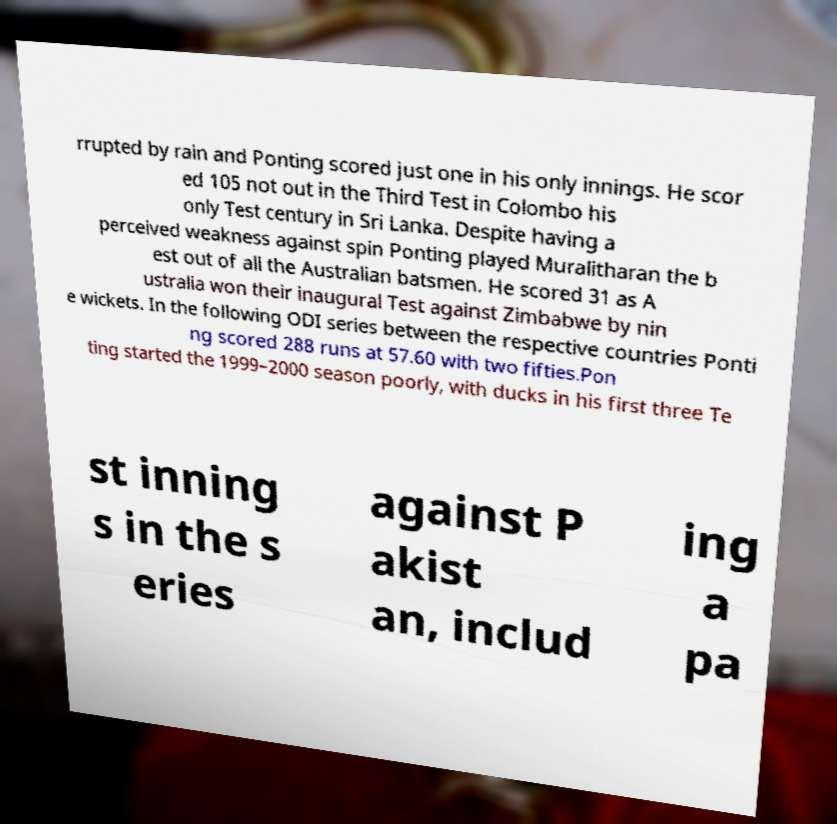I need the written content from this picture converted into text. Can you do that? rrupted by rain and Ponting scored just one in his only innings. He scor ed 105 not out in the Third Test in Colombo his only Test century in Sri Lanka. Despite having a perceived weakness against spin Ponting played Muralitharan the b est out of all the Australian batsmen. He scored 31 as A ustralia won their inaugural Test against Zimbabwe by nin e wickets. In the following ODI series between the respective countries Ponti ng scored 288 runs at 57.60 with two fifties.Pon ting started the 1999–2000 season poorly, with ducks in his first three Te st inning s in the s eries against P akist an, includ ing a pa 